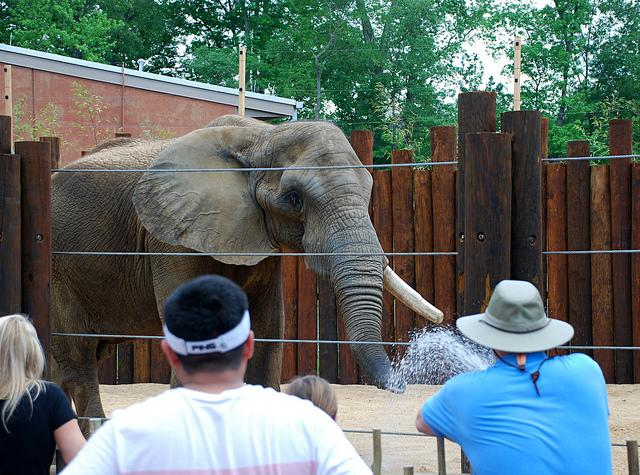What are people watching the elephant likely to use to shoot it? camera 